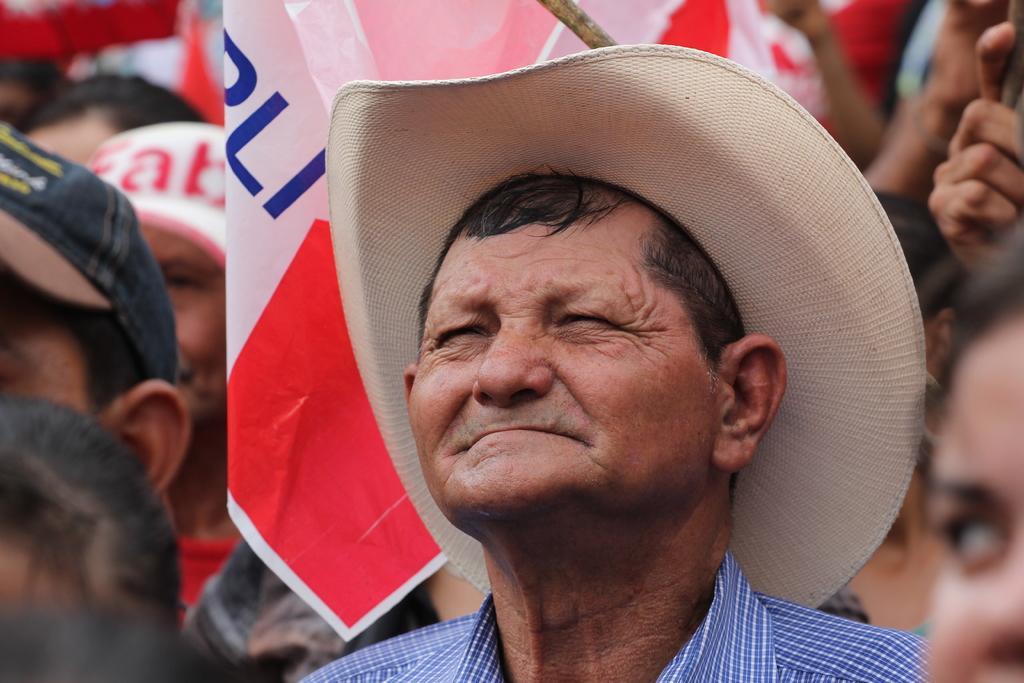How would you summarize this image in a sentence or two? In the image we can see there are many people wearing clothes, this is a flag, this is a hat and this is a cap. 